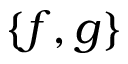<formula> <loc_0><loc_0><loc_500><loc_500>\left \{ f , g \right \}</formula> 